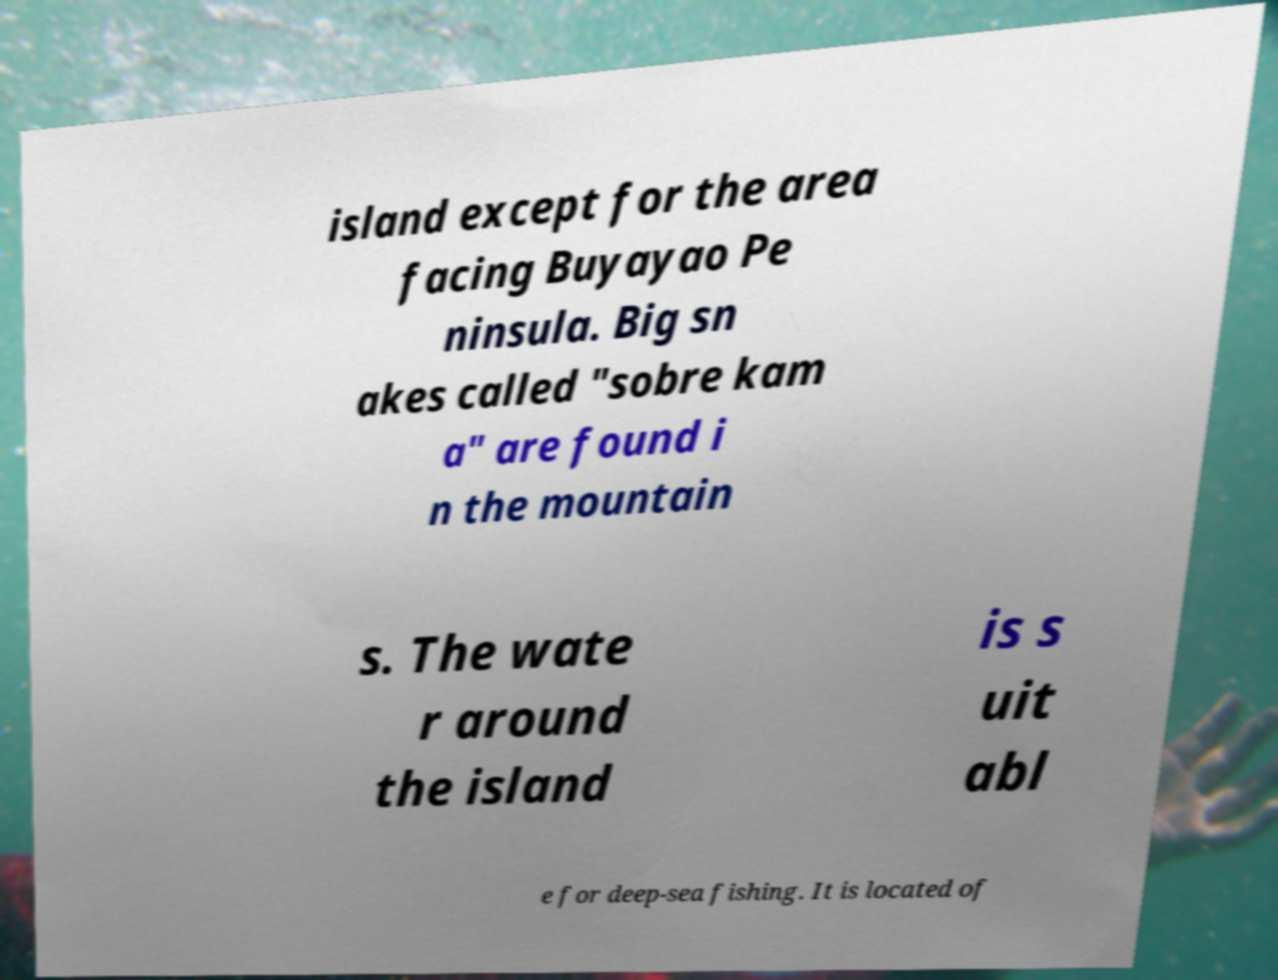Can you read and provide the text displayed in the image?This photo seems to have some interesting text. Can you extract and type it out for me? island except for the area facing Buyayao Pe ninsula. Big sn akes called "sobre kam a" are found i n the mountain s. The wate r around the island is s uit abl e for deep-sea fishing. It is located of 